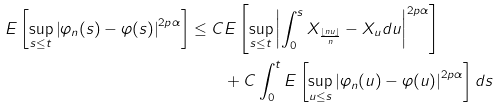Convert formula to latex. <formula><loc_0><loc_0><loc_500><loc_500>E \left [ \sup _ { s \leq t } \left | \varphi _ { n } ( s ) - \varphi ( s ) \right | ^ { 2 p \alpha } \right ] \leq C & E \left [ \sup _ { s \leq t } \left | \int _ { 0 } ^ { s } X _ { \frac { \lfloor n u \rfloor } { n } } - X _ { u } d u \right | ^ { 2 p \alpha } \right ] \\ & + C \int _ { 0 } ^ { t } E \left [ \sup _ { u \leq s } \left | \varphi _ { n } ( u ) - \varphi ( u ) \right | ^ { 2 p \alpha } \right ] d s</formula> 